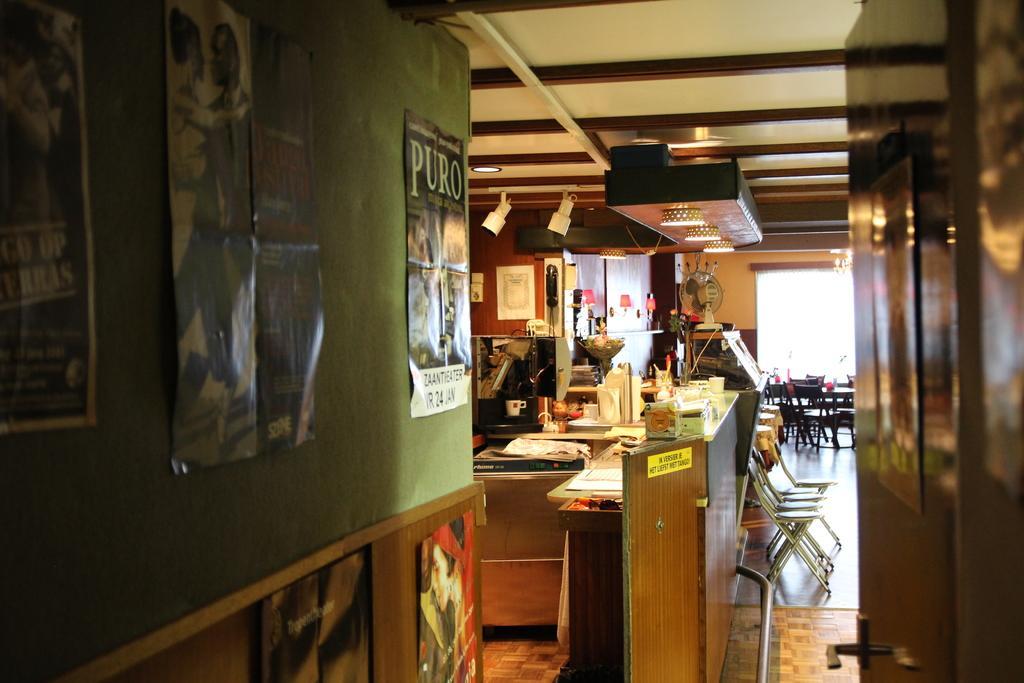Please provide a concise description of this image. In this image we can see there are posters on the wall. In front of the wall there is a door. Through the door there is a cupboard. On that there is a coffee machine, books, bottle, cup, bowl and few objects on it. And at the back there is a lamp. To the side there are chairs, dining table and table fan. And at the top there is a ceiling and lights. 